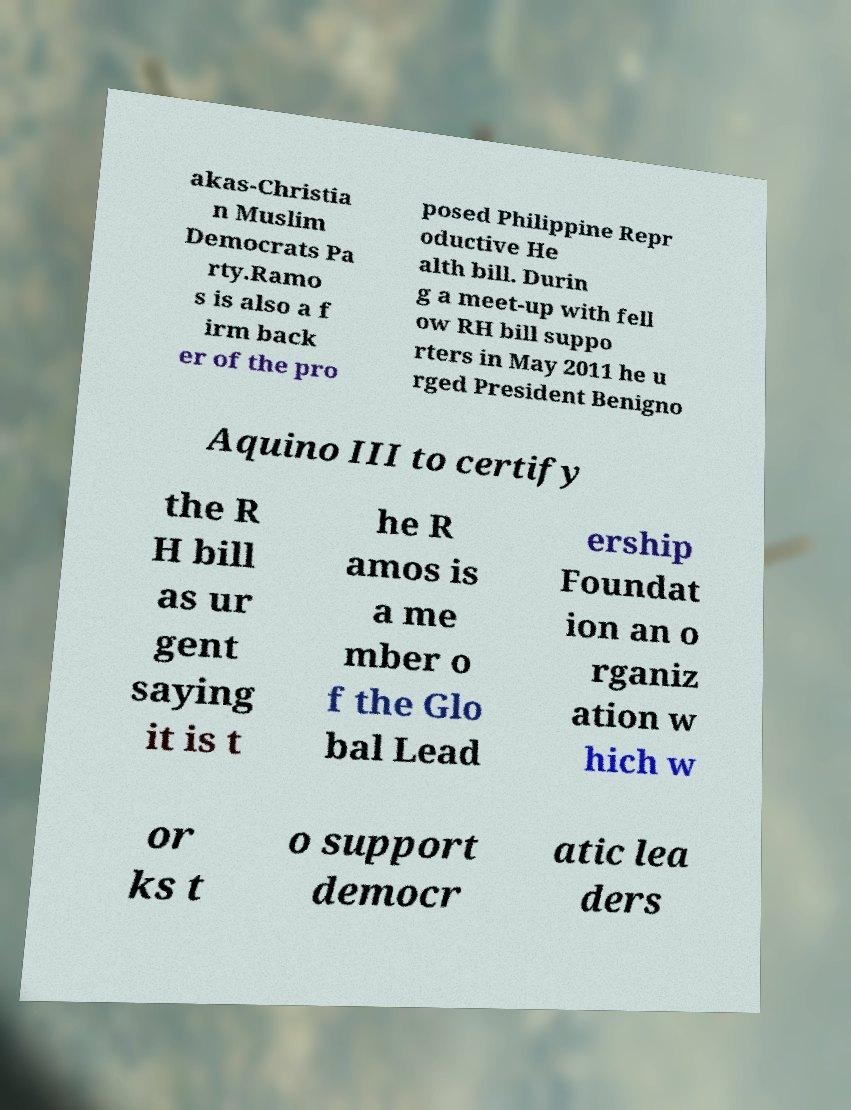I need the written content from this picture converted into text. Can you do that? akas-Christia n Muslim Democrats Pa rty.Ramo s is also a f irm back er of the pro posed Philippine Repr oductive He alth bill. Durin g a meet-up with fell ow RH bill suppo rters in May 2011 he u rged President Benigno Aquino III to certify the R H bill as ur gent saying it is t he R amos is a me mber o f the Glo bal Lead ership Foundat ion an o rganiz ation w hich w or ks t o support democr atic lea ders 